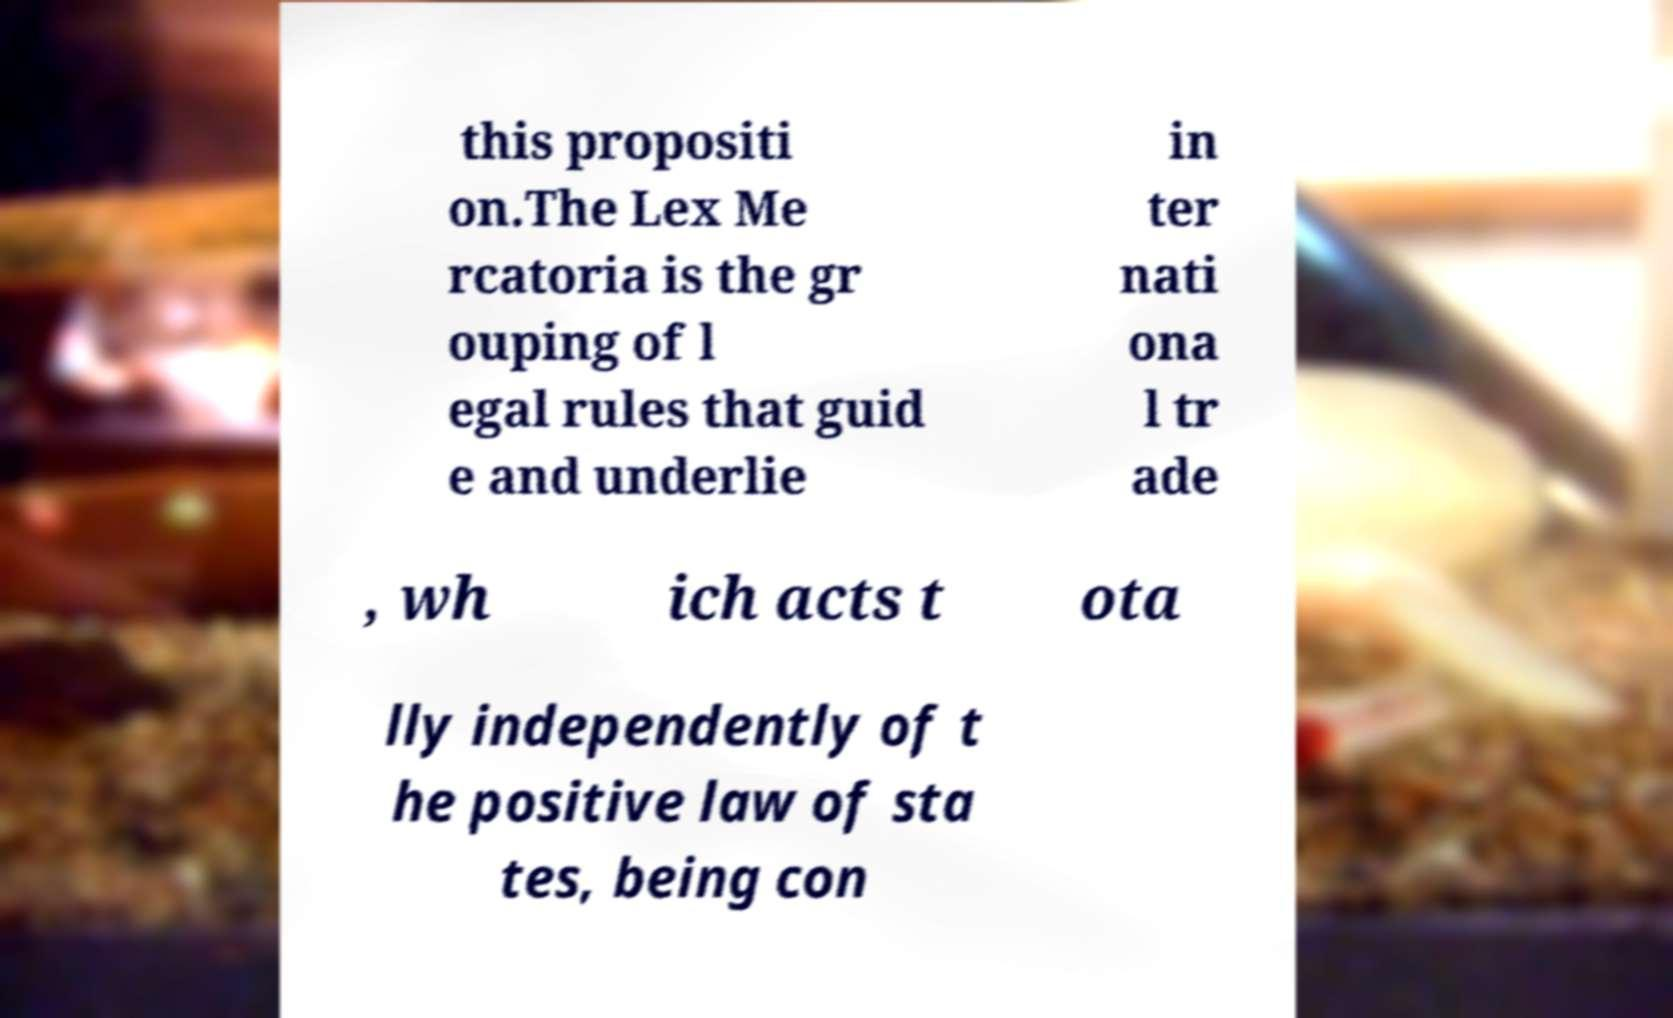Please identify and transcribe the text found in this image. this propositi on.The Lex Me rcatoria is the gr ouping of l egal rules that guid e and underlie in ter nati ona l tr ade , wh ich acts t ota lly independently of t he positive law of sta tes, being con 